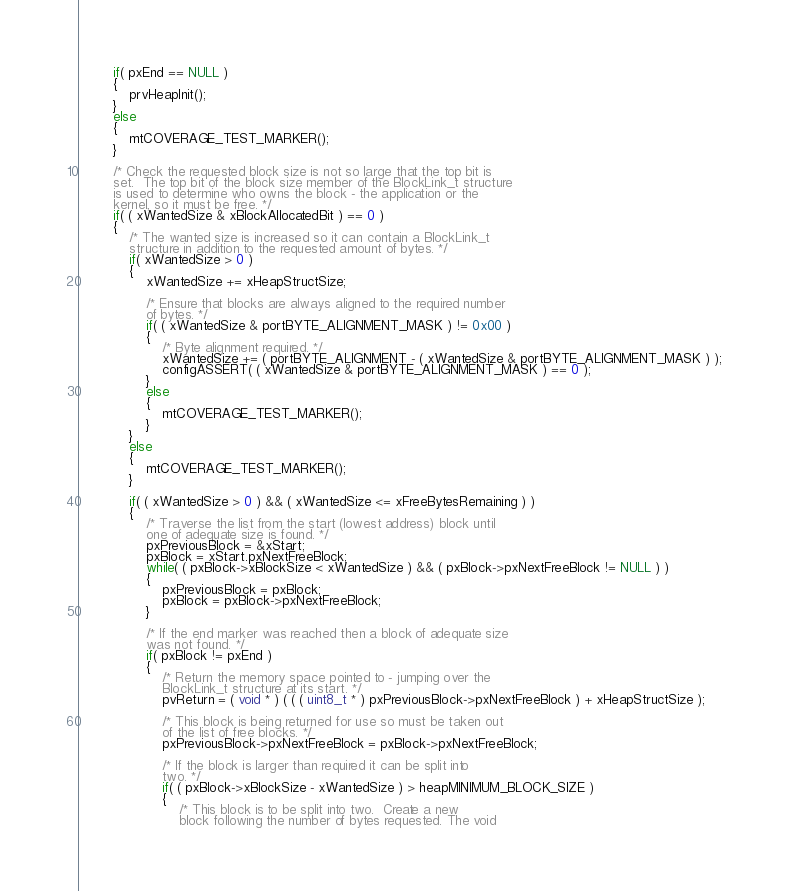<code> <loc_0><loc_0><loc_500><loc_500><_C_>		if( pxEnd == NULL )
		{
			prvHeapInit();
		}
		else
		{
			mtCOVERAGE_TEST_MARKER();
		}

		/* Check the requested block size is not so large that the top bit is
		set.  The top bit of the block size member of the BlockLink_t structure
		is used to determine who owns the block - the application or the
		kernel, so it must be free. */
		if( ( xWantedSize & xBlockAllocatedBit ) == 0 )
		{
			/* The wanted size is increased so it can contain a BlockLink_t
			structure in addition to the requested amount of bytes. */
			if( xWantedSize > 0 )
			{
				xWantedSize += xHeapStructSize;

				/* Ensure that blocks are always aligned to the required number
				of bytes. */
				if( ( xWantedSize & portBYTE_ALIGNMENT_MASK ) != 0x00 )
				{
					/* Byte alignment required. */
					xWantedSize += ( portBYTE_ALIGNMENT - ( xWantedSize & portBYTE_ALIGNMENT_MASK ) );
					configASSERT( ( xWantedSize & portBYTE_ALIGNMENT_MASK ) == 0 );
				}
				else
				{
					mtCOVERAGE_TEST_MARKER();
				}
			}
			else
			{
				mtCOVERAGE_TEST_MARKER();
			}

			if( ( xWantedSize > 0 ) && ( xWantedSize <= xFreeBytesRemaining ) )
			{
				/* Traverse the list from the start	(lowest address) block until
				one	of adequate size is found. */
				pxPreviousBlock = &xStart;
				pxBlock = xStart.pxNextFreeBlock;
				while( ( pxBlock->xBlockSize < xWantedSize ) && ( pxBlock->pxNextFreeBlock != NULL ) )
				{
					pxPreviousBlock = pxBlock;
					pxBlock = pxBlock->pxNextFreeBlock;
				}

				/* If the end marker was reached then a block of adequate size
				was	not found. */
				if( pxBlock != pxEnd )
				{
					/* Return the memory space pointed to - jumping over the
					BlockLink_t structure at its start. */
					pvReturn = ( void * ) ( ( ( uint8_t * ) pxPreviousBlock->pxNextFreeBlock ) + xHeapStructSize );

					/* This block is being returned for use so must be taken out
					of the list of free blocks. */
					pxPreviousBlock->pxNextFreeBlock = pxBlock->pxNextFreeBlock;

					/* If the block is larger than required it can be split into
					two. */
					if( ( pxBlock->xBlockSize - xWantedSize ) > heapMINIMUM_BLOCK_SIZE )
					{
						/* This block is to be split into two.  Create a new
						block following the number of bytes requested. The void</code> 